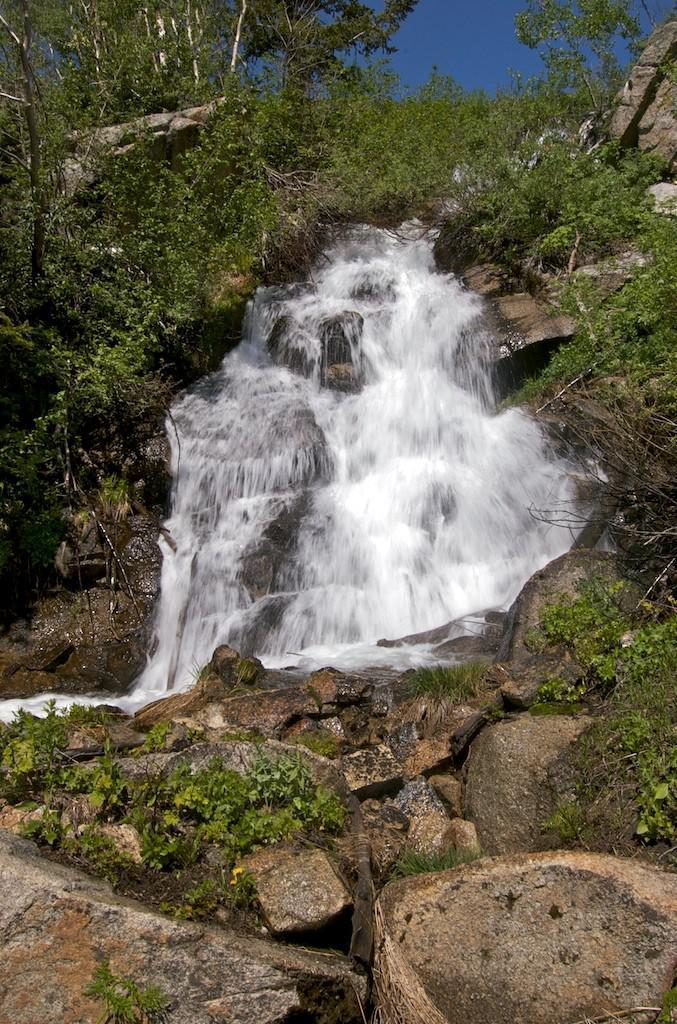What is the main feature in the center of the image? There is a waterfall in the center of the image. What can be seen at the bottom of the image? Rocks are present at the bottom of the image. What is visible at the top of the image? The sky is visible at the top of the image. What type of juice is being served at the waterfall in the image? There is no juice present in the image; it features a waterfall and surrounding landscape. 